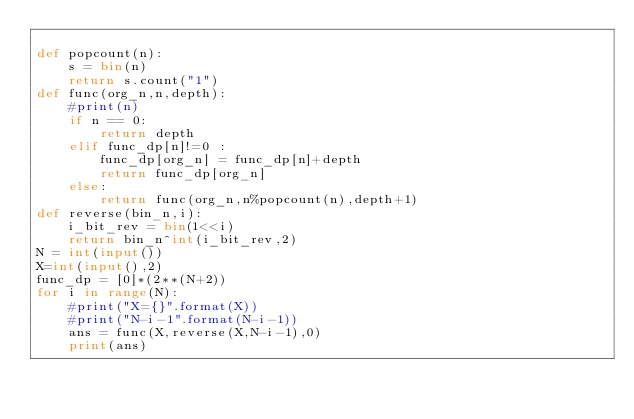<code> <loc_0><loc_0><loc_500><loc_500><_Python_>
def popcount(n):
    s = bin(n)
    return s.count("1")
def func(org_n,n,depth):
    #print(n)
    if n == 0:
        return depth
    elif func_dp[n]!=0 :
        func_dp[org_n] = func_dp[n]+depth
        return func_dp[org_n]
    else:
        return func(org_n,n%popcount(n),depth+1)
def reverse(bin_n,i):
    i_bit_rev = bin(1<<i)
    return bin_n^int(i_bit_rev,2)
N = int(input())
X=int(input(),2)
func_dp = [0]*(2**(N+2))
for i in range(N):
    #print("X={}".format(X))
    #print("N-i-1".format(N-i-1))
    ans = func(X,reverse(X,N-i-1),0)
    print(ans)</code> 